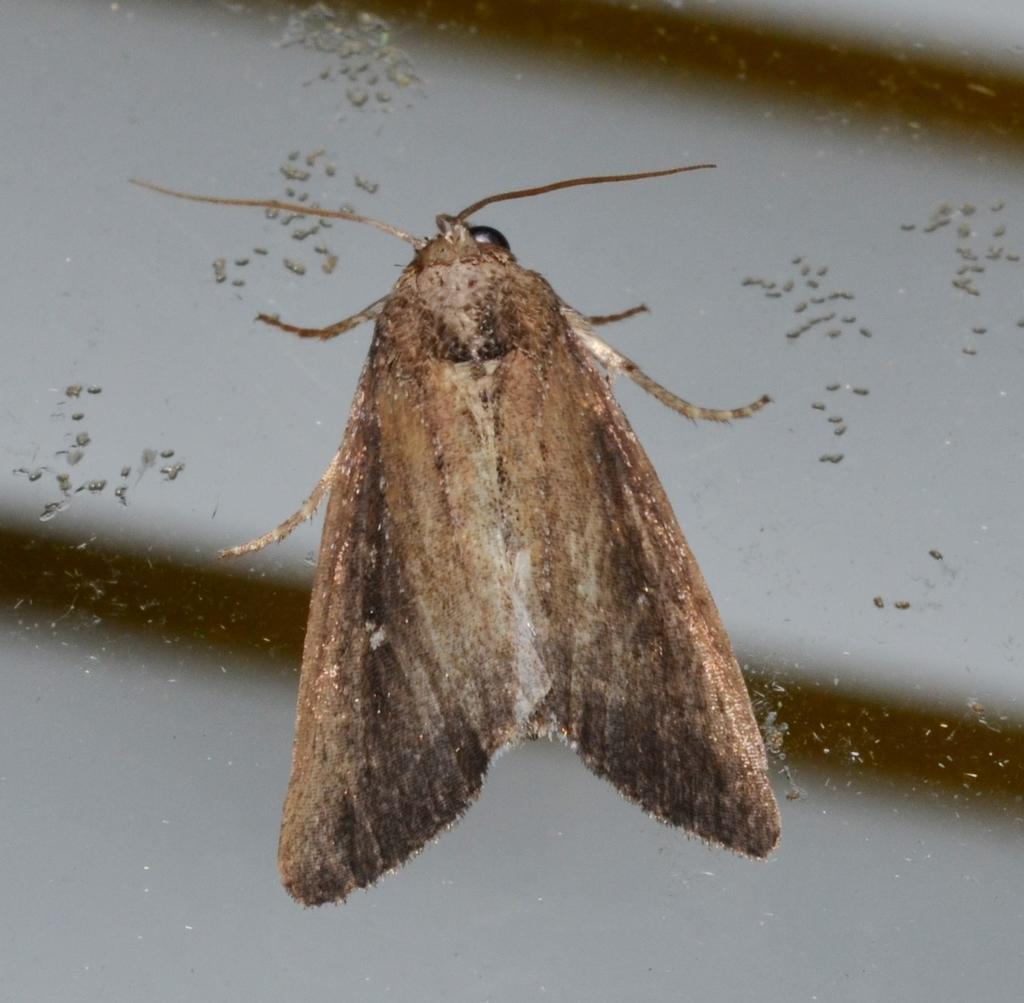Could you give a brief overview of what you see in this image? In the image there is a moth standing on a glass wall. 